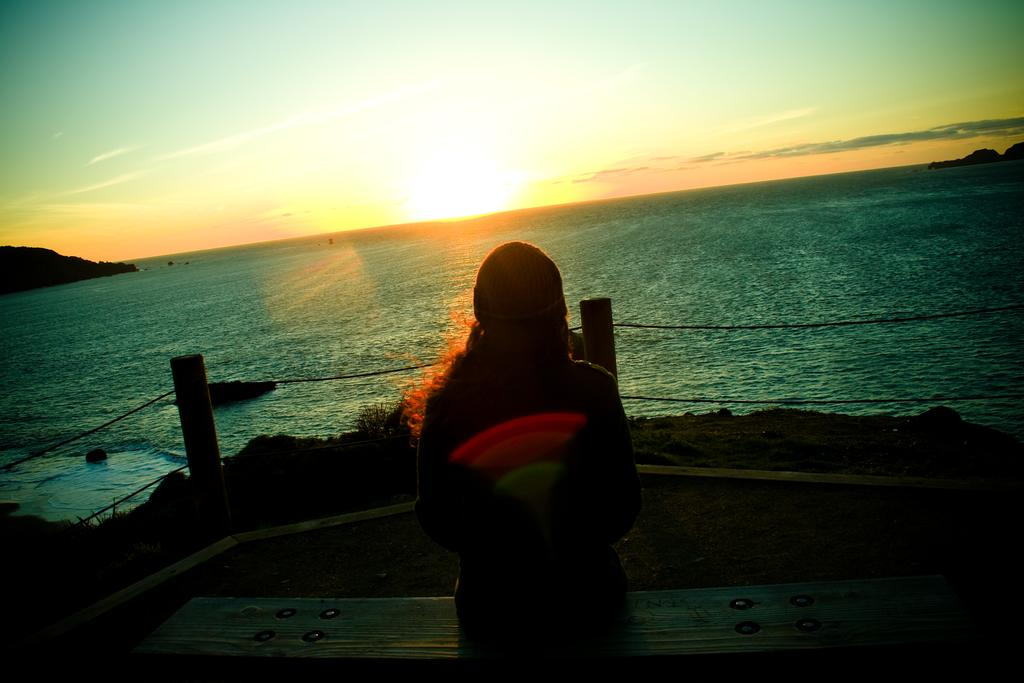What is the woman doing in the image? The woman is sitting on a bench in the image. What objects are located in the center of the image? There are ropes and poles in the center of the image. What type of natural landscape can be seen in the background of the image? Mountains are visible in the background of the image. What celestial body is observable in the sky in the background of the image? The sun is observable in the sky in the background of the image. What type of sleet can be seen falling from the sky in the image? There is no sleet present in the image; the sky is clear, and the sun is visible. 